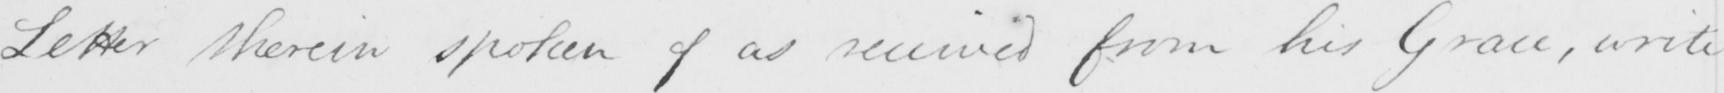Transcribe the text shown in this historical manuscript line. Letter therein spoken of as received from his Grace , write 